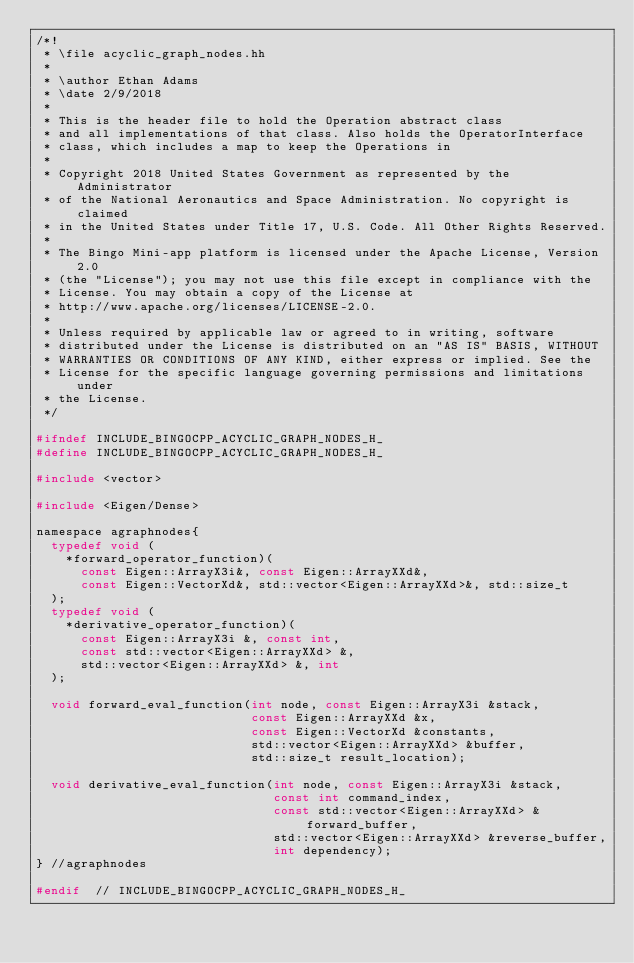<code> <loc_0><loc_0><loc_500><loc_500><_C_>/*!
 * \file acyclic_graph_nodes.hh
 *
 * \author Ethan Adams
 * \date 2/9/2018
 *
 * This is the header file to hold the Operation abstract class
 * and all implementations of that class. Also holds the OperatorInterface
 * class, which includes a map to keep the Operations in
 *
 * Copyright 2018 United States Government as represented by the Administrator 
 * of the National Aeronautics and Space Administration. No copyright is claimed 
 * in the United States under Title 17, U.S. Code. All Other Rights Reserved.
 *
 * The Bingo Mini-app platform is licensed under the Apache License, Version 2.0 
 * (the "License"); you may not use this file except in compliance with the 
 * License. You may obtain a copy of the License at  
 * http://www.apache.org/licenses/LICENSE-2.0. 
 *
 * Unless required by applicable law or agreed to in writing, software 
 * distributed under the License is distributed on an "AS IS" BASIS, WITHOUT 
 * WARRANTIES OR CONDITIONS OF ANY KIND, either express or implied. See the 
 * License for the specific language governing permissions and limitations under 
 * the License.
 */

#ifndef INCLUDE_BINGOCPP_ACYCLIC_GRAPH_NODES_H_
#define INCLUDE_BINGOCPP_ACYCLIC_GRAPH_NODES_H_

#include <vector>

#include <Eigen/Dense>

namespace agraphnodes{
  typedef void (
    *forward_operator_function)(
      const Eigen::ArrayX3i&, const Eigen::ArrayXXd&,
      const Eigen::VectorXd&, std::vector<Eigen::ArrayXXd>&, std::size_t
  );
  typedef void (
    *derivative_operator_function)(
      const Eigen::ArrayX3i &, const int,
      const std::vector<Eigen::ArrayXXd> &,
      std::vector<Eigen::ArrayXXd> &, int
  );
  
  void forward_eval_function(int node, const Eigen::ArrayX3i &stack,
                             const Eigen::ArrayXXd &x,
                             const Eigen::VectorXd &constants,
                             std::vector<Eigen::ArrayXXd> &buffer,
                             std::size_t result_location);

  void derivative_eval_function(int node, const Eigen::ArrayX3i &stack,
                                const int command_index,
                                const std::vector<Eigen::ArrayXXd> &forward_buffer,
                                std::vector<Eigen::ArrayXXd> &reverse_buffer,
                                int dependency);
} //agraphnodes

#endif  // INCLUDE_BINGOCPP_ACYCLIC_GRAPH_NODES_H_
</code> 